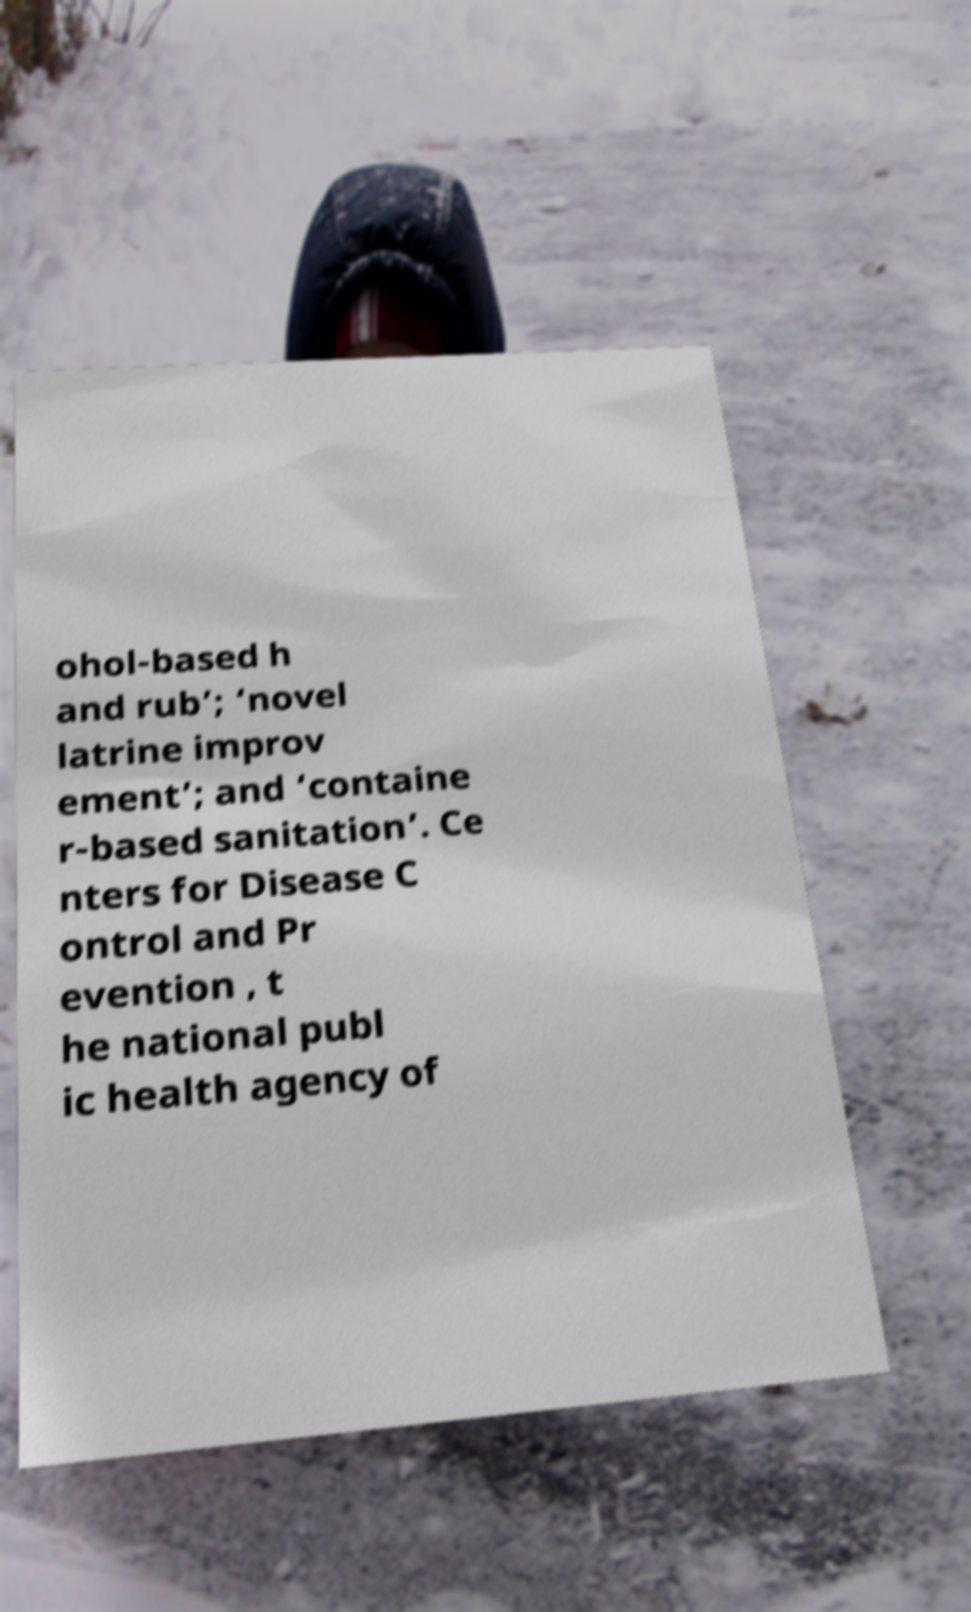I need the written content from this picture converted into text. Can you do that? ohol-based h and rub’; ‘novel latrine improv ement’; and ‘containe r-based sanitation’. Ce nters for Disease C ontrol and Pr evention , t he national publ ic health agency of 